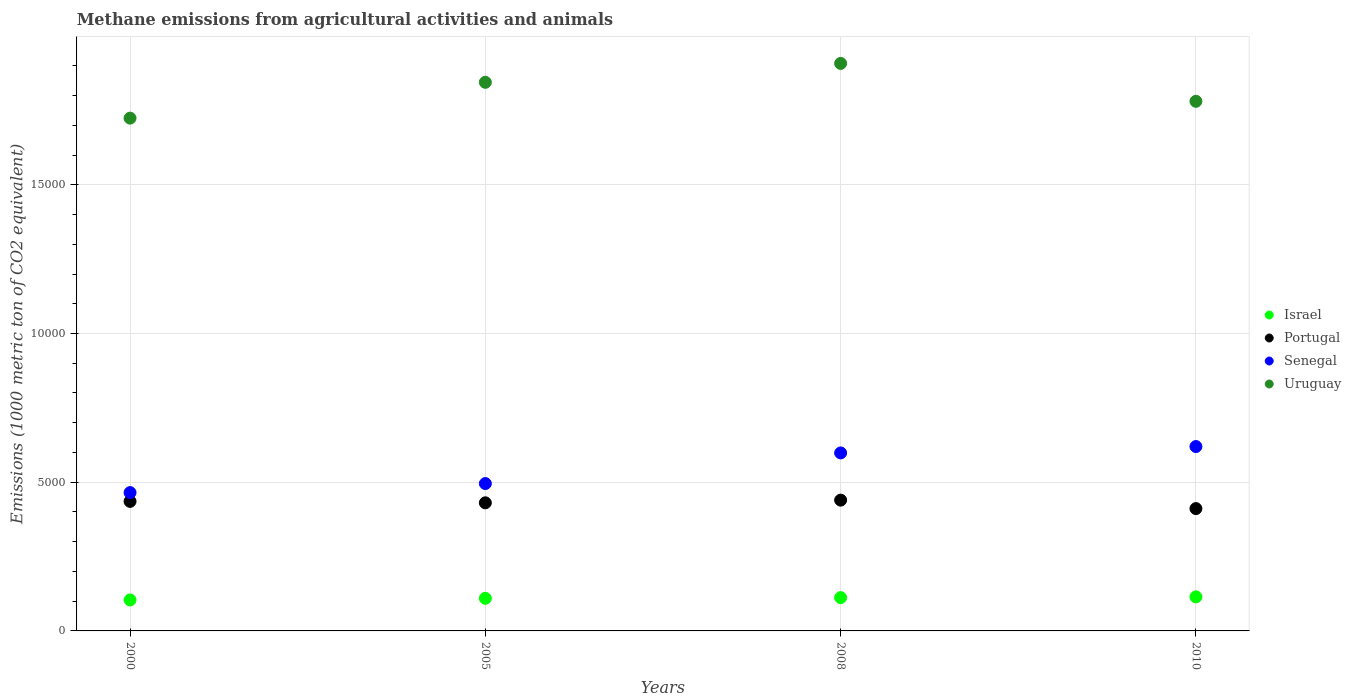How many different coloured dotlines are there?
Provide a short and direct response. 4. What is the amount of methane emitted in Senegal in 2008?
Keep it short and to the point. 5984.9. Across all years, what is the maximum amount of methane emitted in Portugal?
Provide a succinct answer. 4397.6. Across all years, what is the minimum amount of methane emitted in Senegal?
Provide a short and direct response. 4650.7. In which year was the amount of methane emitted in Uruguay maximum?
Make the answer very short. 2008. In which year was the amount of methane emitted in Senegal minimum?
Your answer should be very brief. 2000. What is the total amount of methane emitted in Portugal in the graph?
Offer a terse response. 1.72e+04. What is the difference between the amount of methane emitted in Senegal in 2000 and that in 2005?
Your answer should be compact. -304.4. What is the difference between the amount of methane emitted in Portugal in 2000 and the amount of methane emitted in Uruguay in 2010?
Make the answer very short. -1.35e+04. What is the average amount of methane emitted in Israel per year?
Provide a short and direct response. 1100.67. In the year 2005, what is the difference between the amount of methane emitted in Israel and amount of methane emitted in Senegal?
Your answer should be very brief. -3859.2. In how many years, is the amount of methane emitted in Senegal greater than 2000 1000 metric ton?
Your answer should be compact. 4. What is the ratio of the amount of methane emitted in Uruguay in 2000 to that in 2010?
Make the answer very short. 0.97. Is the difference between the amount of methane emitted in Israel in 2000 and 2008 greater than the difference between the amount of methane emitted in Senegal in 2000 and 2008?
Ensure brevity in your answer.  Yes. What is the difference between the highest and the second highest amount of methane emitted in Portugal?
Offer a terse response. 42.2. What is the difference between the highest and the lowest amount of methane emitted in Senegal?
Provide a succinct answer. 1548.4. Is it the case that in every year, the sum of the amount of methane emitted in Senegal and amount of methane emitted in Portugal  is greater than the amount of methane emitted in Uruguay?
Provide a succinct answer. No. Does the amount of methane emitted in Senegal monotonically increase over the years?
Provide a succinct answer. Yes. Is the amount of methane emitted in Israel strictly greater than the amount of methane emitted in Portugal over the years?
Your response must be concise. No. How many dotlines are there?
Your answer should be compact. 4. How many years are there in the graph?
Provide a succinct answer. 4. What is the difference between two consecutive major ticks on the Y-axis?
Offer a very short reply. 5000. Are the values on the major ticks of Y-axis written in scientific E-notation?
Provide a short and direct response. No. Does the graph contain any zero values?
Give a very brief answer. No. Where does the legend appear in the graph?
Make the answer very short. Center right. How many legend labels are there?
Your response must be concise. 4. How are the legend labels stacked?
Make the answer very short. Vertical. What is the title of the graph?
Ensure brevity in your answer.  Methane emissions from agricultural activities and animals. What is the label or title of the X-axis?
Your answer should be very brief. Years. What is the label or title of the Y-axis?
Your answer should be compact. Emissions (1000 metric ton of CO2 equivalent). What is the Emissions (1000 metric ton of CO2 equivalent) of Israel in 2000?
Your answer should be compact. 1041.6. What is the Emissions (1000 metric ton of CO2 equivalent) in Portugal in 2000?
Give a very brief answer. 4355.4. What is the Emissions (1000 metric ton of CO2 equivalent) in Senegal in 2000?
Your answer should be very brief. 4650.7. What is the Emissions (1000 metric ton of CO2 equivalent) in Uruguay in 2000?
Provide a short and direct response. 1.72e+04. What is the Emissions (1000 metric ton of CO2 equivalent) of Israel in 2005?
Make the answer very short. 1095.9. What is the Emissions (1000 metric ton of CO2 equivalent) in Portugal in 2005?
Your response must be concise. 4307.2. What is the Emissions (1000 metric ton of CO2 equivalent) in Senegal in 2005?
Your response must be concise. 4955.1. What is the Emissions (1000 metric ton of CO2 equivalent) of Uruguay in 2005?
Ensure brevity in your answer.  1.84e+04. What is the Emissions (1000 metric ton of CO2 equivalent) of Israel in 2008?
Your response must be concise. 1119.7. What is the Emissions (1000 metric ton of CO2 equivalent) of Portugal in 2008?
Your answer should be compact. 4397.6. What is the Emissions (1000 metric ton of CO2 equivalent) of Senegal in 2008?
Your answer should be very brief. 5984.9. What is the Emissions (1000 metric ton of CO2 equivalent) of Uruguay in 2008?
Your response must be concise. 1.91e+04. What is the Emissions (1000 metric ton of CO2 equivalent) in Israel in 2010?
Offer a very short reply. 1145.5. What is the Emissions (1000 metric ton of CO2 equivalent) in Portugal in 2010?
Provide a succinct answer. 4113.1. What is the Emissions (1000 metric ton of CO2 equivalent) of Senegal in 2010?
Give a very brief answer. 6199.1. What is the Emissions (1000 metric ton of CO2 equivalent) in Uruguay in 2010?
Provide a succinct answer. 1.78e+04. Across all years, what is the maximum Emissions (1000 metric ton of CO2 equivalent) of Israel?
Your answer should be very brief. 1145.5. Across all years, what is the maximum Emissions (1000 metric ton of CO2 equivalent) of Portugal?
Ensure brevity in your answer.  4397.6. Across all years, what is the maximum Emissions (1000 metric ton of CO2 equivalent) of Senegal?
Provide a succinct answer. 6199.1. Across all years, what is the maximum Emissions (1000 metric ton of CO2 equivalent) in Uruguay?
Keep it short and to the point. 1.91e+04. Across all years, what is the minimum Emissions (1000 metric ton of CO2 equivalent) of Israel?
Your answer should be very brief. 1041.6. Across all years, what is the minimum Emissions (1000 metric ton of CO2 equivalent) of Portugal?
Your answer should be compact. 4113.1. Across all years, what is the minimum Emissions (1000 metric ton of CO2 equivalent) in Senegal?
Offer a terse response. 4650.7. Across all years, what is the minimum Emissions (1000 metric ton of CO2 equivalent) of Uruguay?
Offer a terse response. 1.72e+04. What is the total Emissions (1000 metric ton of CO2 equivalent) of Israel in the graph?
Offer a terse response. 4402.7. What is the total Emissions (1000 metric ton of CO2 equivalent) in Portugal in the graph?
Your response must be concise. 1.72e+04. What is the total Emissions (1000 metric ton of CO2 equivalent) of Senegal in the graph?
Ensure brevity in your answer.  2.18e+04. What is the total Emissions (1000 metric ton of CO2 equivalent) in Uruguay in the graph?
Your answer should be very brief. 7.26e+04. What is the difference between the Emissions (1000 metric ton of CO2 equivalent) of Israel in 2000 and that in 2005?
Keep it short and to the point. -54.3. What is the difference between the Emissions (1000 metric ton of CO2 equivalent) in Portugal in 2000 and that in 2005?
Your response must be concise. 48.2. What is the difference between the Emissions (1000 metric ton of CO2 equivalent) in Senegal in 2000 and that in 2005?
Keep it short and to the point. -304.4. What is the difference between the Emissions (1000 metric ton of CO2 equivalent) in Uruguay in 2000 and that in 2005?
Keep it short and to the point. -1204.8. What is the difference between the Emissions (1000 metric ton of CO2 equivalent) in Israel in 2000 and that in 2008?
Keep it short and to the point. -78.1. What is the difference between the Emissions (1000 metric ton of CO2 equivalent) of Portugal in 2000 and that in 2008?
Give a very brief answer. -42.2. What is the difference between the Emissions (1000 metric ton of CO2 equivalent) in Senegal in 2000 and that in 2008?
Offer a terse response. -1334.2. What is the difference between the Emissions (1000 metric ton of CO2 equivalent) in Uruguay in 2000 and that in 2008?
Make the answer very short. -1840.5. What is the difference between the Emissions (1000 metric ton of CO2 equivalent) in Israel in 2000 and that in 2010?
Make the answer very short. -103.9. What is the difference between the Emissions (1000 metric ton of CO2 equivalent) of Portugal in 2000 and that in 2010?
Provide a succinct answer. 242.3. What is the difference between the Emissions (1000 metric ton of CO2 equivalent) of Senegal in 2000 and that in 2010?
Make the answer very short. -1548.4. What is the difference between the Emissions (1000 metric ton of CO2 equivalent) in Uruguay in 2000 and that in 2010?
Your answer should be very brief. -565.4. What is the difference between the Emissions (1000 metric ton of CO2 equivalent) of Israel in 2005 and that in 2008?
Provide a short and direct response. -23.8. What is the difference between the Emissions (1000 metric ton of CO2 equivalent) in Portugal in 2005 and that in 2008?
Make the answer very short. -90.4. What is the difference between the Emissions (1000 metric ton of CO2 equivalent) of Senegal in 2005 and that in 2008?
Keep it short and to the point. -1029.8. What is the difference between the Emissions (1000 metric ton of CO2 equivalent) of Uruguay in 2005 and that in 2008?
Your response must be concise. -635.7. What is the difference between the Emissions (1000 metric ton of CO2 equivalent) in Israel in 2005 and that in 2010?
Give a very brief answer. -49.6. What is the difference between the Emissions (1000 metric ton of CO2 equivalent) in Portugal in 2005 and that in 2010?
Give a very brief answer. 194.1. What is the difference between the Emissions (1000 metric ton of CO2 equivalent) of Senegal in 2005 and that in 2010?
Your response must be concise. -1244. What is the difference between the Emissions (1000 metric ton of CO2 equivalent) of Uruguay in 2005 and that in 2010?
Give a very brief answer. 639.4. What is the difference between the Emissions (1000 metric ton of CO2 equivalent) in Israel in 2008 and that in 2010?
Your answer should be compact. -25.8. What is the difference between the Emissions (1000 metric ton of CO2 equivalent) of Portugal in 2008 and that in 2010?
Your answer should be very brief. 284.5. What is the difference between the Emissions (1000 metric ton of CO2 equivalent) of Senegal in 2008 and that in 2010?
Your answer should be very brief. -214.2. What is the difference between the Emissions (1000 metric ton of CO2 equivalent) in Uruguay in 2008 and that in 2010?
Ensure brevity in your answer.  1275.1. What is the difference between the Emissions (1000 metric ton of CO2 equivalent) in Israel in 2000 and the Emissions (1000 metric ton of CO2 equivalent) in Portugal in 2005?
Your answer should be very brief. -3265.6. What is the difference between the Emissions (1000 metric ton of CO2 equivalent) of Israel in 2000 and the Emissions (1000 metric ton of CO2 equivalent) of Senegal in 2005?
Provide a short and direct response. -3913.5. What is the difference between the Emissions (1000 metric ton of CO2 equivalent) in Israel in 2000 and the Emissions (1000 metric ton of CO2 equivalent) in Uruguay in 2005?
Your response must be concise. -1.74e+04. What is the difference between the Emissions (1000 metric ton of CO2 equivalent) in Portugal in 2000 and the Emissions (1000 metric ton of CO2 equivalent) in Senegal in 2005?
Offer a terse response. -599.7. What is the difference between the Emissions (1000 metric ton of CO2 equivalent) of Portugal in 2000 and the Emissions (1000 metric ton of CO2 equivalent) of Uruguay in 2005?
Ensure brevity in your answer.  -1.41e+04. What is the difference between the Emissions (1000 metric ton of CO2 equivalent) of Senegal in 2000 and the Emissions (1000 metric ton of CO2 equivalent) of Uruguay in 2005?
Offer a terse response. -1.38e+04. What is the difference between the Emissions (1000 metric ton of CO2 equivalent) in Israel in 2000 and the Emissions (1000 metric ton of CO2 equivalent) in Portugal in 2008?
Provide a short and direct response. -3356. What is the difference between the Emissions (1000 metric ton of CO2 equivalent) in Israel in 2000 and the Emissions (1000 metric ton of CO2 equivalent) in Senegal in 2008?
Your answer should be compact. -4943.3. What is the difference between the Emissions (1000 metric ton of CO2 equivalent) in Israel in 2000 and the Emissions (1000 metric ton of CO2 equivalent) in Uruguay in 2008?
Offer a very short reply. -1.80e+04. What is the difference between the Emissions (1000 metric ton of CO2 equivalent) in Portugal in 2000 and the Emissions (1000 metric ton of CO2 equivalent) in Senegal in 2008?
Your response must be concise. -1629.5. What is the difference between the Emissions (1000 metric ton of CO2 equivalent) of Portugal in 2000 and the Emissions (1000 metric ton of CO2 equivalent) of Uruguay in 2008?
Offer a very short reply. -1.47e+04. What is the difference between the Emissions (1000 metric ton of CO2 equivalent) in Senegal in 2000 and the Emissions (1000 metric ton of CO2 equivalent) in Uruguay in 2008?
Your answer should be compact. -1.44e+04. What is the difference between the Emissions (1000 metric ton of CO2 equivalent) in Israel in 2000 and the Emissions (1000 metric ton of CO2 equivalent) in Portugal in 2010?
Make the answer very short. -3071.5. What is the difference between the Emissions (1000 metric ton of CO2 equivalent) of Israel in 2000 and the Emissions (1000 metric ton of CO2 equivalent) of Senegal in 2010?
Give a very brief answer. -5157.5. What is the difference between the Emissions (1000 metric ton of CO2 equivalent) in Israel in 2000 and the Emissions (1000 metric ton of CO2 equivalent) in Uruguay in 2010?
Offer a very short reply. -1.68e+04. What is the difference between the Emissions (1000 metric ton of CO2 equivalent) of Portugal in 2000 and the Emissions (1000 metric ton of CO2 equivalent) of Senegal in 2010?
Keep it short and to the point. -1843.7. What is the difference between the Emissions (1000 metric ton of CO2 equivalent) of Portugal in 2000 and the Emissions (1000 metric ton of CO2 equivalent) of Uruguay in 2010?
Offer a terse response. -1.35e+04. What is the difference between the Emissions (1000 metric ton of CO2 equivalent) of Senegal in 2000 and the Emissions (1000 metric ton of CO2 equivalent) of Uruguay in 2010?
Give a very brief answer. -1.32e+04. What is the difference between the Emissions (1000 metric ton of CO2 equivalent) of Israel in 2005 and the Emissions (1000 metric ton of CO2 equivalent) of Portugal in 2008?
Your answer should be very brief. -3301.7. What is the difference between the Emissions (1000 metric ton of CO2 equivalent) in Israel in 2005 and the Emissions (1000 metric ton of CO2 equivalent) in Senegal in 2008?
Your response must be concise. -4889. What is the difference between the Emissions (1000 metric ton of CO2 equivalent) of Israel in 2005 and the Emissions (1000 metric ton of CO2 equivalent) of Uruguay in 2008?
Give a very brief answer. -1.80e+04. What is the difference between the Emissions (1000 metric ton of CO2 equivalent) in Portugal in 2005 and the Emissions (1000 metric ton of CO2 equivalent) in Senegal in 2008?
Your answer should be compact. -1677.7. What is the difference between the Emissions (1000 metric ton of CO2 equivalent) in Portugal in 2005 and the Emissions (1000 metric ton of CO2 equivalent) in Uruguay in 2008?
Provide a succinct answer. -1.48e+04. What is the difference between the Emissions (1000 metric ton of CO2 equivalent) in Senegal in 2005 and the Emissions (1000 metric ton of CO2 equivalent) in Uruguay in 2008?
Your answer should be very brief. -1.41e+04. What is the difference between the Emissions (1000 metric ton of CO2 equivalent) of Israel in 2005 and the Emissions (1000 metric ton of CO2 equivalent) of Portugal in 2010?
Ensure brevity in your answer.  -3017.2. What is the difference between the Emissions (1000 metric ton of CO2 equivalent) of Israel in 2005 and the Emissions (1000 metric ton of CO2 equivalent) of Senegal in 2010?
Offer a very short reply. -5103.2. What is the difference between the Emissions (1000 metric ton of CO2 equivalent) of Israel in 2005 and the Emissions (1000 metric ton of CO2 equivalent) of Uruguay in 2010?
Provide a short and direct response. -1.67e+04. What is the difference between the Emissions (1000 metric ton of CO2 equivalent) of Portugal in 2005 and the Emissions (1000 metric ton of CO2 equivalent) of Senegal in 2010?
Your answer should be very brief. -1891.9. What is the difference between the Emissions (1000 metric ton of CO2 equivalent) of Portugal in 2005 and the Emissions (1000 metric ton of CO2 equivalent) of Uruguay in 2010?
Offer a very short reply. -1.35e+04. What is the difference between the Emissions (1000 metric ton of CO2 equivalent) in Senegal in 2005 and the Emissions (1000 metric ton of CO2 equivalent) in Uruguay in 2010?
Ensure brevity in your answer.  -1.29e+04. What is the difference between the Emissions (1000 metric ton of CO2 equivalent) of Israel in 2008 and the Emissions (1000 metric ton of CO2 equivalent) of Portugal in 2010?
Your response must be concise. -2993.4. What is the difference between the Emissions (1000 metric ton of CO2 equivalent) in Israel in 2008 and the Emissions (1000 metric ton of CO2 equivalent) in Senegal in 2010?
Provide a short and direct response. -5079.4. What is the difference between the Emissions (1000 metric ton of CO2 equivalent) in Israel in 2008 and the Emissions (1000 metric ton of CO2 equivalent) in Uruguay in 2010?
Offer a terse response. -1.67e+04. What is the difference between the Emissions (1000 metric ton of CO2 equivalent) in Portugal in 2008 and the Emissions (1000 metric ton of CO2 equivalent) in Senegal in 2010?
Make the answer very short. -1801.5. What is the difference between the Emissions (1000 metric ton of CO2 equivalent) in Portugal in 2008 and the Emissions (1000 metric ton of CO2 equivalent) in Uruguay in 2010?
Offer a terse response. -1.34e+04. What is the difference between the Emissions (1000 metric ton of CO2 equivalent) in Senegal in 2008 and the Emissions (1000 metric ton of CO2 equivalent) in Uruguay in 2010?
Your answer should be compact. -1.18e+04. What is the average Emissions (1000 metric ton of CO2 equivalent) of Israel per year?
Offer a very short reply. 1100.67. What is the average Emissions (1000 metric ton of CO2 equivalent) in Portugal per year?
Offer a terse response. 4293.32. What is the average Emissions (1000 metric ton of CO2 equivalent) of Senegal per year?
Provide a short and direct response. 5447.45. What is the average Emissions (1000 metric ton of CO2 equivalent) of Uruguay per year?
Keep it short and to the point. 1.81e+04. In the year 2000, what is the difference between the Emissions (1000 metric ton of CO2 equivalent) in Israel and Emissions (1000 metric ton of CO2 equivalent) in Portugal?
Offer a very short reply. -3313.8. In the year 2000, what is the difference between the Emissions (1000 metric ton of CO2 equivalent) of Israel and Emissions (1000 metric ton of CO2 equivalent) of Senegal?
Your response must be concise. -3609.1. In the year 2000, what is the difference between the Emissions (1000 metric ton of CO2 equivalent) in Israel and Emissions (1000 metric ton of CO2 equivalent) in Uruguay?
Ensure brevity in your answer.  -1.62e+04. In the year 2000, what is the difference between the Emissions (1000 metric ton of CO2 equivalent) of Portugal and Emissions (1000 metric ton of CO2 equivalent) of Senegal?
Offer a very short reply. -295.3. In the year 2000, what is the difference between the Emissions (1000 metric ton of CO2 equivalent) in Portugal and Emissions (1000 metric ton of CO2 equivalent) in Uruguay?
Make the answer very short. -1.29e+04. In the year 2000, what is the difference between the Emissions (1000 metric ton of CO2 equivalent) in Senegal and Emissions (1000 metric ton of CO2 equivalent) in Uruguay?
Provide a succinct answer. -1.26e+04. In the year 2005, what is the difference between the Emissions (1000 metric ton of CO2 equivalent) of Israel and Emissions (1000 metric ton of CO2 equivalent) of Portugal?
Your answer should be compact. -3211.3. In the year 2005, what is the difference between the Emissions (1000 metric ton of CO2 equivalent) in Israel and Emissions (1000 metric ton of CO2 equivalent) in Senegal?
Offer a very short reply. -3859.2. In the year 2005, what is the difference between the Emissions (1000 metric ton of CO2 equivalent) in Israel and Emissions (1000 metric ton of CO2 equivalent) in Uruguay?
Give a very brief answer. -1.73e+04. In the year 2005, what is the difference between the Emissions (1000 metric ton of CO2 equivalent) in Portugal and Emissions (1000 metric ton of CO2 equivalent) in Senegal?
Your answer should be very brief. -647.9. In the year 2005, what is the difference between the Emissions (1000 metric ton of CO2 equivalent) of Portugal and Emissions (1000 metric ton of CO2 equivalent) of Uruguay?
Keep it short and to the point. -1.41e+04. In the year 2005, what is the difference between the Emissions (1000 metric ton of CO2 equivalent) in Senegal and Emissions (1000 metric ton of CO2 equivalent) in Uruguay?
Provide a short and direct response. -1.35e+04. In the year 2008, what is the difference between the Emissions (1000 metric ton of CO2 equivalent) in Israel and Emissions (1000 metric ton of CO2 equivalent) in Portugal?
Give a very brief answer. -3277.9. In the year 2008, what is the difference between the Emissions (1000 metric ton of CO2 equivalent) in Israel and Emissions (1000 metric ton of CO2 equivalent) in Senegal?
Give a very brief answer. -4865.2. In the year 2008, what is the difference between the Emissions (1000 metric ton of CO2 equivalent) in Israel and Emissions (1000 metric ton of CO2 equivalent) in Uruguay?
Your answer should be compact. -1.80e+04. In the year 2008, what is the difference between the Emissions (1000 metric ton of CO2 equivalent) of Portugal and Emissions (1000 metric ton of CO2 equivalent) of Senegal?
Offer a terse response. -1587.3. In the year 2008, what is the difference between the Emissions (1000 metric ton of CO2 equivalent) in Portugal and Emissions (1000 metric ton of CO2 equivalent) in Uruguay?
Ensure brevity in your answer.  -1.47e+04. In the year 2008, what is the difference between the Emissions (1000 metric ton of CO2 equivalent) of Senegal and Emissions (1000 metric ton of CO2 equivalent) of Uruguay?
Your response must be concise. -1.31e+04. In the year 2010, what is the difference between the Emissions (1000 metric ton of CO2 equivalent) of Israel and Emissions (1000 metric ton of CO2 equivalent) of Portugal?
Your response must be concise. -2967.6. In the year 2010, what is the difference between the Emissions (1000 metric ton of CO2 equivalent) in Israel and Emissions (1000 metric ton of CO2 equivalent) in Senegal?
Your answer should be very brief. -5053.6. In the year 2010, what is the difference between the Emissions (1000 metric ton of CO2 equivalent) of Israel and Emissions (1000 metric ton of CO2 equivalent) of Uruguay?
Your answer should be compact. -1.67e+04. In the year 2010, what is the difference between the Emissions (1000 metric ton of CO2 equivalent) in Portugal and Emissions (1000 metric ton of CO2 equivalent) in Senegal?
Provide a short and direct response. -2086. In the year 2010, what is the difference between the Emissions (1000 metric ton of CO2 equivalent) of Portugal and Emissions (1000 metric ton of CO2 equivalent) of Uruguay?
Your answer should be very brief. -1.37e+04. In the year 2010, what is the difference between the Emissions (1000 metric ton of CO2 equivalent) of Senegal and Emissions (1000 metric ton of CO2 equivalent) of Uruguay?
Make the answer very short. -1.16e+04. What is the ratio of the Emissions (1000 metric ton of CO2 equivalent) of Israel in 2000 to that in 2005?
Your answer should be very brief. 0.95. What is the ratio of the Emissions (1000 metric ton of CO2 equivalent) in Portugal in 2000 to that in 2005?
Ensure brevity in your answer.  1.01. What is the ratio of the Emissions (1000 metric ton of CO2 equivalent) of Senegal in 2000 to that in 2005?
Provide a short and direct response. 0.94. What is the ratio of the Emissions (1000 metric ton of CO2 equivalent) of Uruguay in 2000 to that in 2005?
Your answer should be very brief. 0.93. What is the ratio of the Emissions (1000 metric ton of CO2 equivalent) of Israel in 2000 to that in 2008?
Provide a succinct answer. 0.93. What is the ratio of the Emissions (1000 metric ton of CO2 equivalent) of Portugal in 2000 to that in 2008?
Ensure brevity in your answer.  0.99. What is the ratio of the Emissions (1000 metric ton of CO2 equivalent) in Senegal in 2000 to that in 2008?
Provide a short and direct response. 0.78. What is the ratio of the Emissions (1000 metric ton of CO2 equivalent) of Uruguay in 2000 to that in 2008?
Ensure brevity in your answer.  0.9. What is the ratio of the Emissions (1000 metric ton of CO2 equivalent) of Israel in 2000 to that in 2010?
Offer a terse response. 0.91. What is the ratio of the Emissions (1000 metric ton of CO2 equivalent) of Portugal in 2000 to that in 2010?
Offer a terse response. 1.06. What is the ratio of the Emissions (1000 metric ton of CO2 equivalent) of Senegal in 2000 to that in 2010?
Provide a succinct answer. 0.75. What is the ratio of the Emissions (1000 metric ton of CO2 equivalent) of Uruguay in 2000 to that in 2010?
Ensure brevity in your answer.  0.97. What is the ratio of the Emissions (1000 metric ton of CO2 equivalent) in Israel in 2005 to that in 2008?
Offer a very short reply. 0.98. What is the ratio of the Emissions (1000 metric ton of CO2 equivalent) of Portugal in 2005 to that in 2008?
Ensure brevity in your answer.  0.98. What is the ratio of the Emissions (1000 metric ton of CO2 equivalent) in Senegal in 2005 to that in 2008?
Your answer should be compact. 0.83. What is the ratio of the Emissions (1000 metric ton of CO2 equivalent) of Uruguay in 2005 to that in 2008?
Your answer should be very brief. 0.97. What is the ratio of the Emissions (1000 metric ton of CO2 equivalent) in Israel in 2005 to that in 2010?
Ensure brevity in your answer.  0.96. What is the ratio of the Emissions (1000 metric ton of CO2 equivalent) in Portugal in 2005 to that in 2010?
Ensure brevity in your answer.  1.05. What is the ratio of the Emissions (1000 metric ton of CO2 equivalent) of Senegal in 2005 to that in 2010?
Ensure brevity in your answer.  0.8. What is the ratio of the Emissions (1000 metric ton of CO2 equivalent) in Uruguay in 2005 to that in 2010?
Keep it short and to the point. 1.04. What is the ratio of the Emissions (1000 metric ton of CO2 equivalent) of Israel in 2008 to that in 2010?
Ensure brevity in your answer.  0.98. What is the ratio of the Emissions (1000 metric ton of CO2 equivalent) in Portugal in 2008 to that in 2010?
Offer a terse response. 1.07. What is the ratio of the Emissions (1000 metric ton of CO2 equivalent) of Senegal in 2008 to that in 2010?
Keep it short and to the point. 0.97. What is the ratio of the Emissions (1000 metric ton of CO2 equivalent) of Uruguay in 2008 to that in 2010?
Provide a short and direct response. 1.07. What is the difference between the highest and the second highest Emissions (1000 metric ton of CO2 equivalent) in Israel?
Offer a very short reply. 25.8. What is the difference between the highest and the second highest Emissions (1000 metric ton of CO2 equivalent) in Portugal?
Offer a terse response. 42.2. What is the difference between the highest and the second highest Emissions (1000 metric ton of CO2 equivalent) of Senegal?
Provide a succinct answer. 214.2. What is the difference between the highest and the second highest Emissions (1000 metric ton of CO2 equivalent) of Uruguay?
Offer a terse response. 635.7. What is the difference between the highest and the lowest Emissions (1000 metric ton of CO2 equivalent) in Israel?
Ensure brevity in your answer.  103.9. What is the difference between the highest and the lowest Emissions (1000 metric ton of CO2 equivalent) of Portugal?
Provide a short and direct response. 284.5. What is the difference between the highest and the lowest Emissions (1000 metric ton of CO2 equivalent) in Senegal?
Your answer should be very brief. 1548.4. What is the difference between the highest and the lowest Emissions (1000 metric ton of CO2 equivalent) of Uruguay?
Ensure brevity in your answer.  1840.5. 